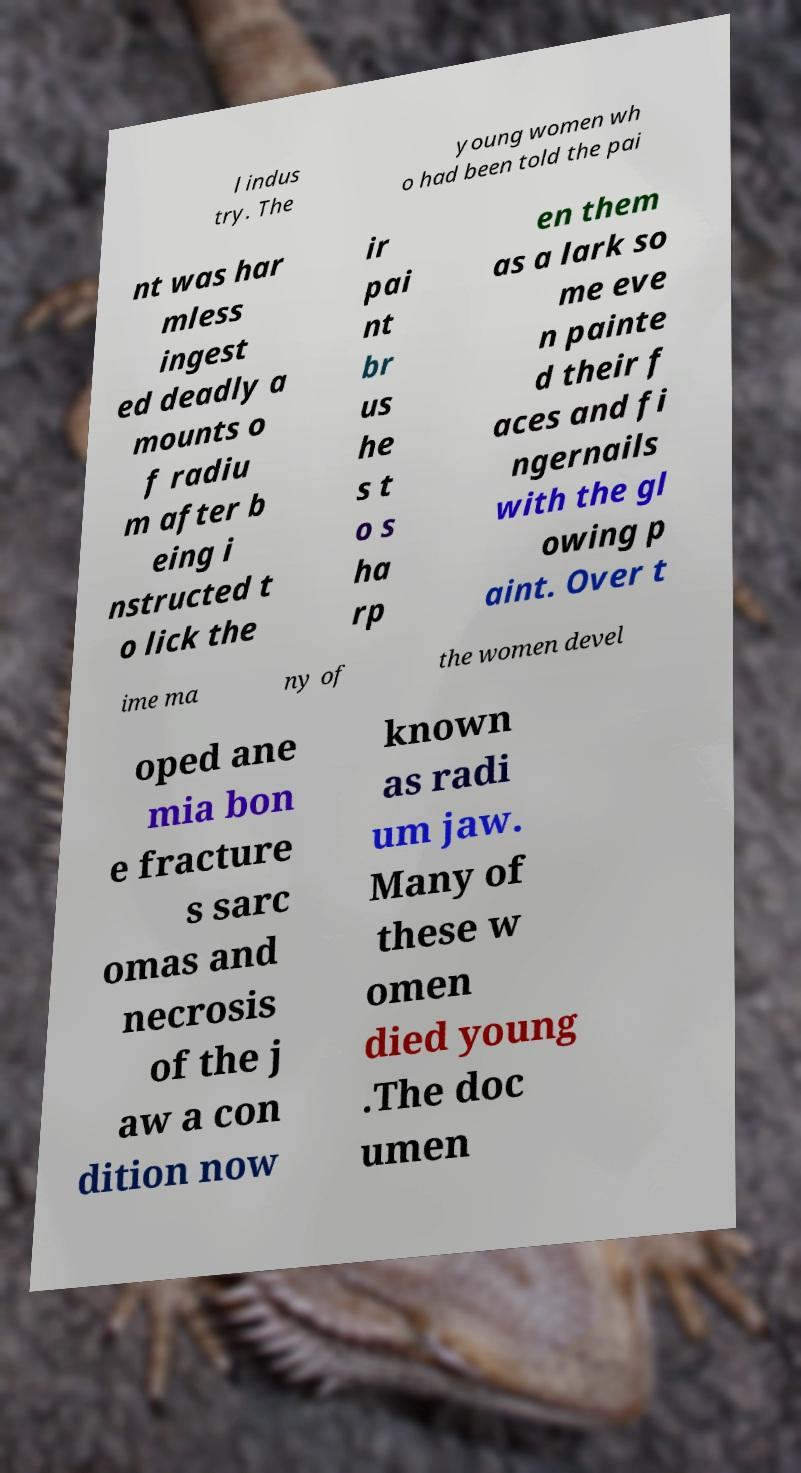Can you accurately transcribe the text from the provided image for me? l indus try. The young women wh o had been told the pai nt was har mless ingest ed deadly a mounts o f radiu m after b eing i nstructed t o lick the ir pai nt br us he s t o s ha rp en them as a lark so me eve n painte d their f aces and fi ngernails with the gl owing p aint. Over t ime ma ny of the women devel oped ane mia bon e fracture s sarc omas and necrosis of the j aw a con dition now known as radi um jaw. Many of these w omen died young .The doc umen 